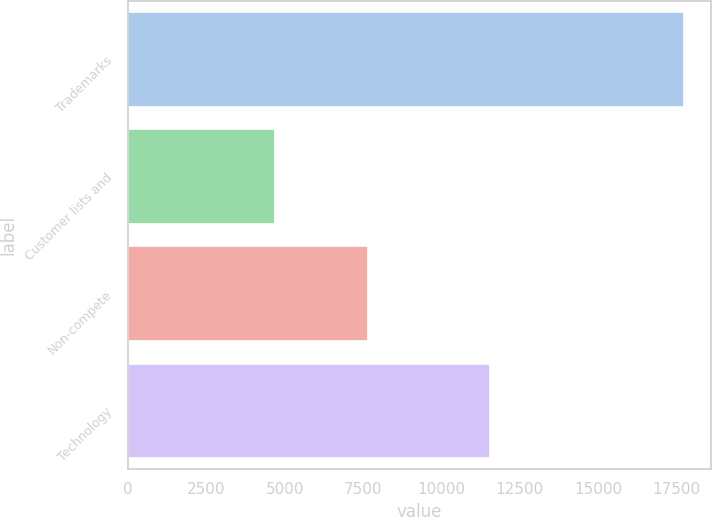Convert chart to OTSL. <chart><loc_0><loc_0><loc_500><loc_500><bar_chart><fcel>Trademarks<fcel>Customer lists and<fcel>Non-compete<fcel>Technology<nl><fcel>17716<fcel>4673<fcel>7617<fcel>11509<nl></chart> 